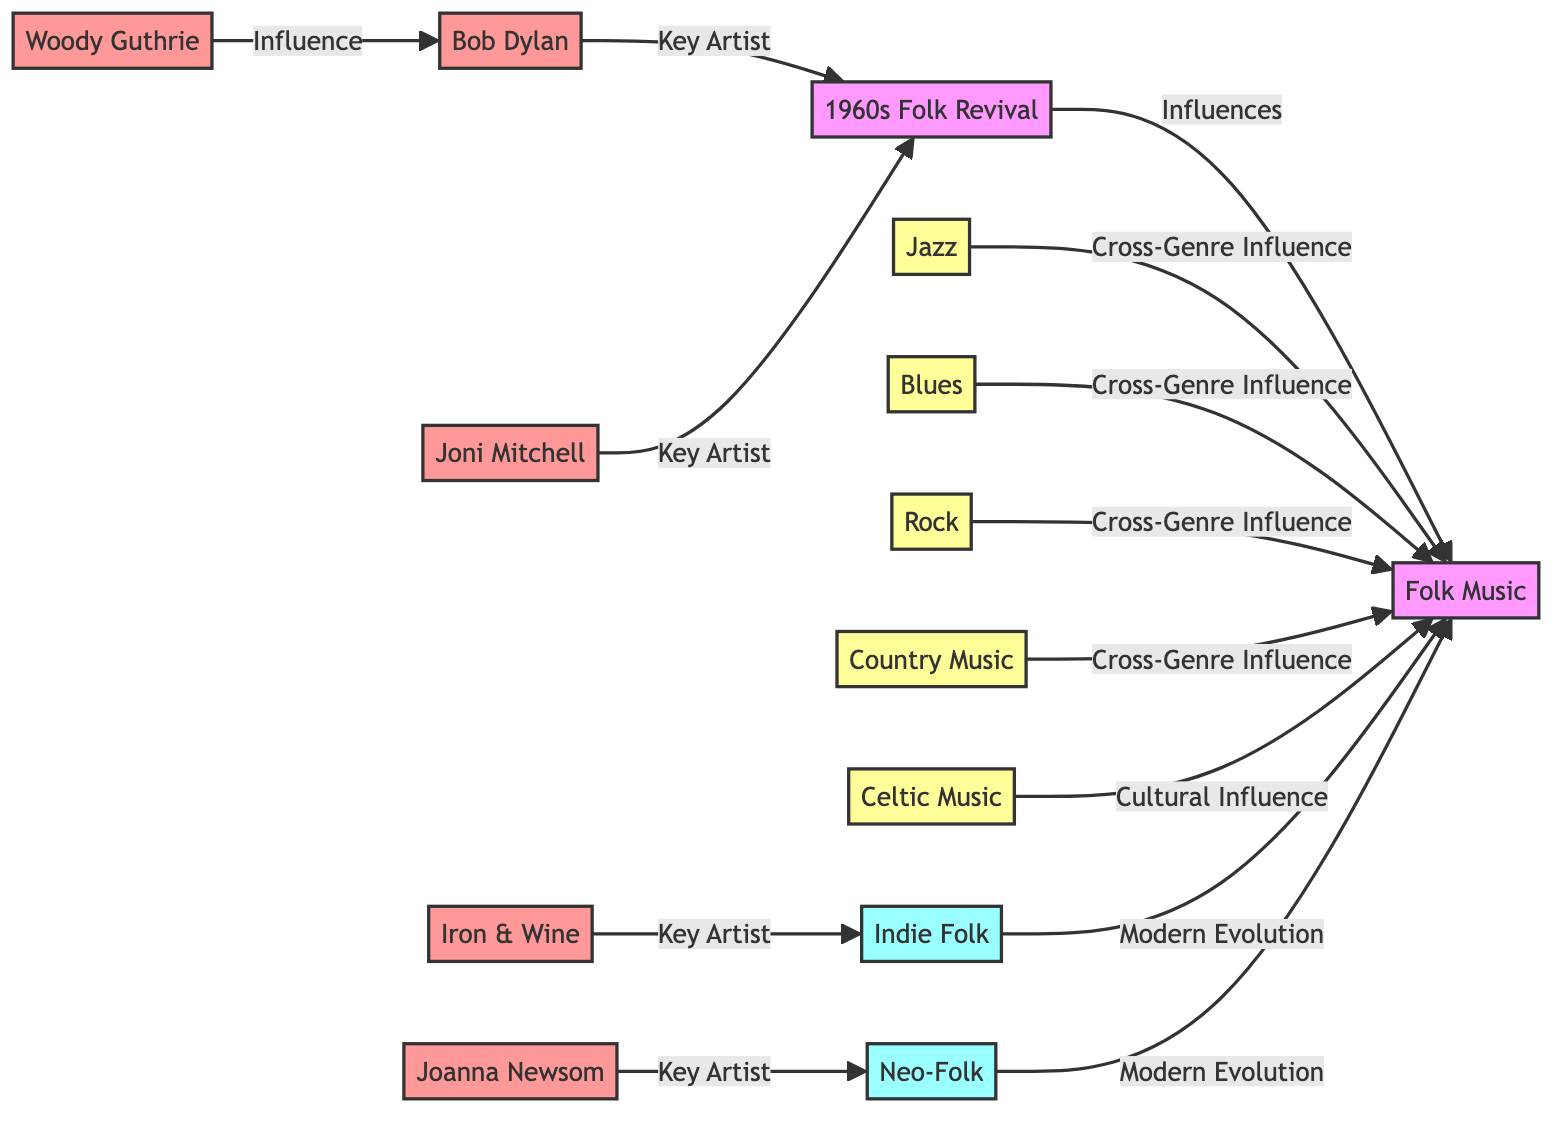What is the total number of nodes in the diagram? By counting the total number of distinct entities represented in the diagram, we find there are 13 nodes listed: Folk Music, 1960s Folk Revival, Bob Dylan, Woody Guthrie, Jazz, Blues, Rock, Joni Mitchell, Country Music, Celtic Music, Indie Folk, Iron & Wine, Neo-Folk, Joanna Newsom.
Answer: 13 Which musical genre influences Folk Music through cultural means? Identifying the relationships in the diagram, we see that Celtic Music is specifically labeled as a cultural influence on Folk Music, distinct from other types of influence such as cross-genre or modern evolution.
Answer: Celtic Music Who is indicated as a key artist for Indie Folk? The diagram shows that Iron & Wine has a direct link marked as a key artist influencing Indie Folk, meaning it is specifically highlighted as a notable contributor within that genre.
Answer: Iron & Wine What is the relationship between Blues and Folk Music? The diagram illustrates that Blues has a directed edge pointing to Folk Music with the label "Cross-Genre Influence". This signifies that Blues is one of the genres that has influenced Folk Music's evolution.
Answer: Cross-Genre Influence How many key artists are associated with the 1960s Folk Revival? By inspecting the diagram, we determine that there are two key artists associated with the 1960s Folk Revival: Bob Dylan and Joni Mitchell, both labeled clearly as key artists.
Answer: 2 Which artist influences Neo-Folk? According to the diagram, Joanna Newsom is indicated as the artist who has a direct influence on Neo-Folk, denoted in the relationship between her and Neo-Folk.
Answer: Joanna Newsom What genre is classified as having cross-genre influence on Folk Music besides Blues? The diagram shows several genres influencing Folk Music, among them Jazz, Rock, and Country Music can also be categorized as cross-genre influences, but the phraseology "besides Blues" indicates excluding that option. Therefore, any of the other three can answer this, but for this one by listing we'll say Jazz as one example.
Answer: Jazz Identify one key artist linked directly to Folk Music through the 1960s Folk Revival. From the diagram, both Bob Dylan and Joni Mitchell are marked as key artists connecting to the 1960s Folk Revival; thus, choosing either will fulfill the question. We'll indicate Bob Dylan as the first visible in the graph for a direct connection.
Answer: Bob Dylan Which node depicts modern evolution of Folk Music? The diagram marks both Indie Folk and Neo-Folk under the label modern evolution, signalling these as contemporary developments stemming from Folk Music itself.
Answer: Indie Folk 